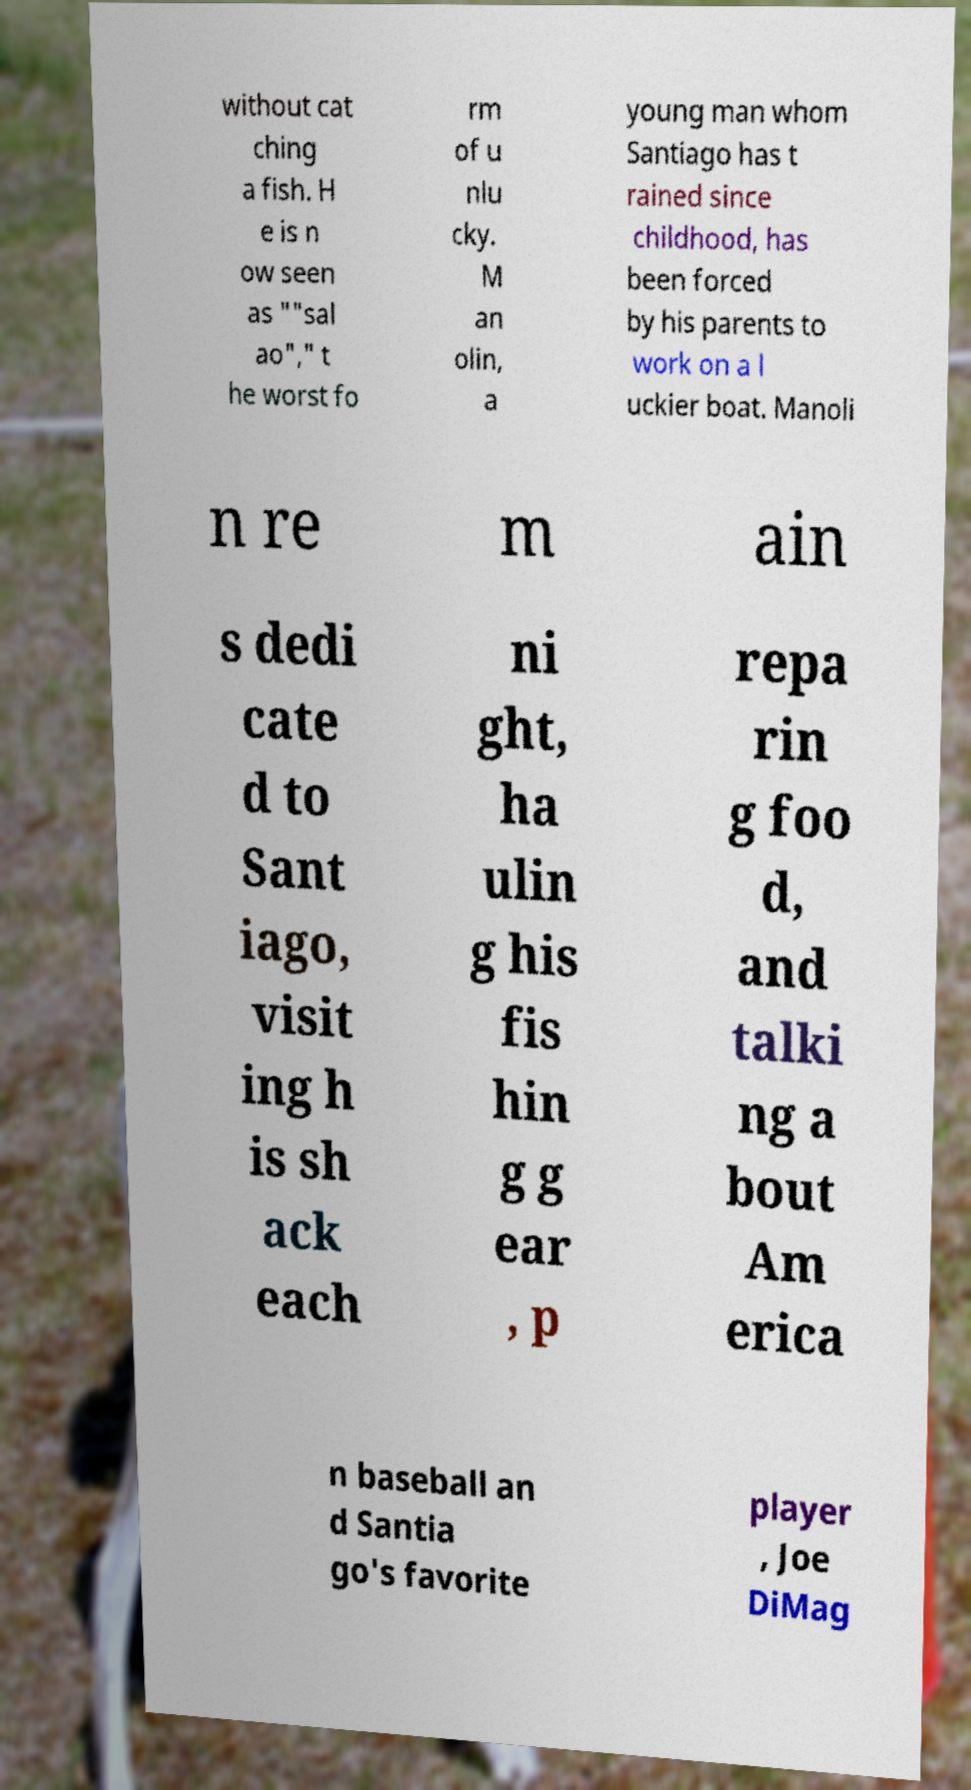Please read and relay the text visible in this image. What does it say? without cat ching a fish. H e is n ow seen as ""sal ao"," t he worst fo rm of u nlu cky. M an olin, a young man whom Santiago has t rained since childhood, has been forced by his parents to work on a l uckier boat. Manoli n re m ain s dedi cate d to Sant iago, visit ing h is sh ack each ni ght, ha ulin g his fis hin g g ear , p repa rin g foo d, and talki ng a bout Am erica n baseball an d Santia go's favorite player , Joe DiMag 